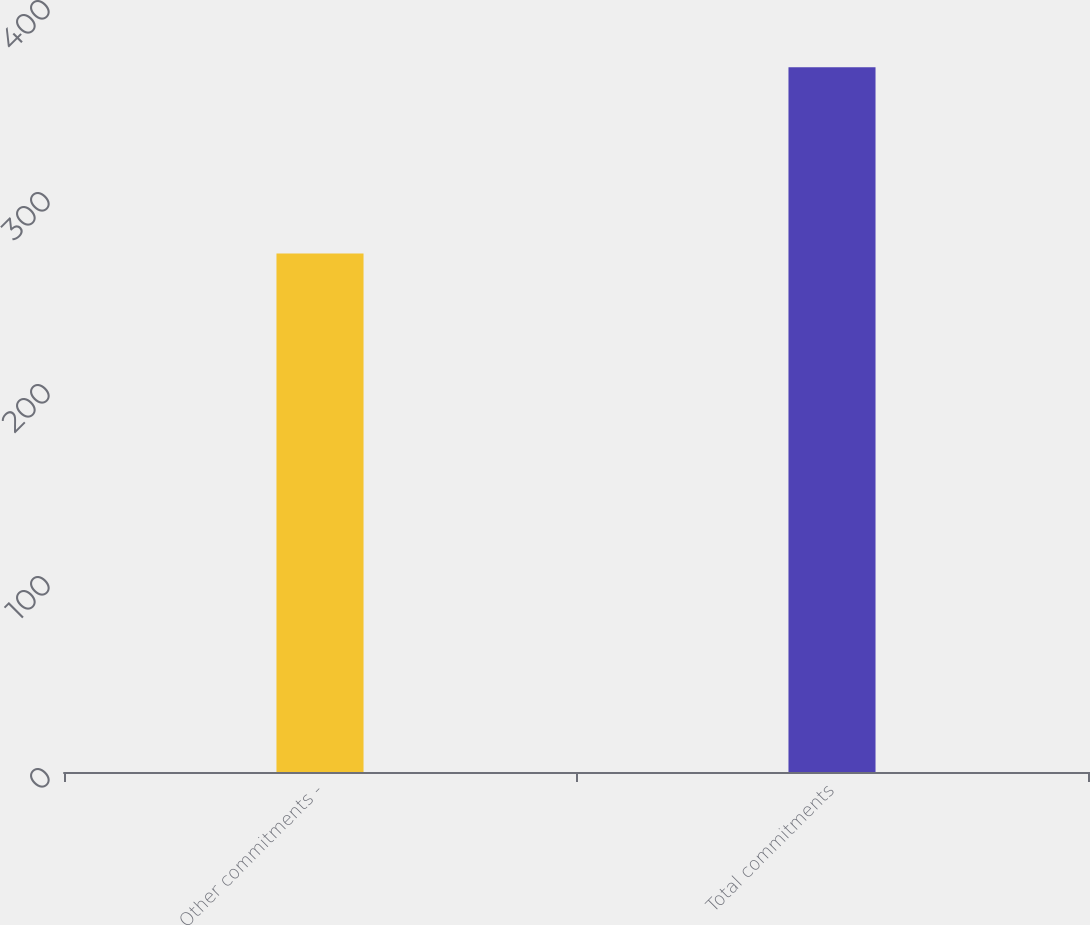Convert chart to OTSL. <chart><loc_0><loc_0><loc_500><loc_500><bar_chart><fcel>Other commitments -<fcel>Total commitments<nl><fcel>270<fcel>367<nl></chart> 